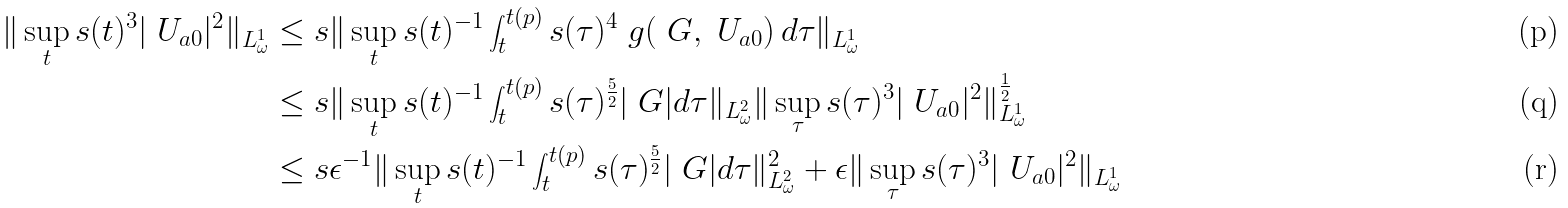<formula> <loc_0><loc_0><loc_500><loc_500>\| \sup _ { t } s ( t ) ^ { 3 } | \ U _ { a 0 } | ^ { 2 } \| _ { L ^ { 1 } _ { \omega } } & \leq s \| \sup _ { t } s ( t ) ^ { - 1 } \int _ { t } ^ { t ( p ) } s ( \tau ) ^ { 4 } \ g ( \ G , \ U _ { a 0 } ) \, d \tau \| _ { L ^ { 1 } _ { \omega } } \\ & \leq s \| \sup _ { t } s ( t ) ^ { - 1 } \int _ { t } ^ { t ( p ) } s ( \tau ) ^ { \frac { 5 } { 2 } } | \ G | d \tau \| _ { L ^ { 2 } _ { \omega } } \| \sup _ { \tau } s ( \tau ) ^ { 3 } | \ U _ { a 0 } | ^ { 2 } \| _ { L ^ { 1 } _ { \omega } } ^ { \frac { 1 } { 2 } } \\ & \leq s \epsilon ^ { - 1 } \| \sup _ { t } s ( t ) ^ { - 1 } \int _ { t } ^ { t ( p ) } s ( \tau ) ^ { \frac { 5 } { 2 } } | \ G | d \tau \| ^ { 2 } _ { L ^ { 2 } _ { \omega } } + \epsilon \| \sup _ { \tau } s ( \tau ) ^ { 3 } | \ U _ { a 0 } | ^ { 2 } \| _ { L ^ { 1 } _ { \omega } }</formula> 